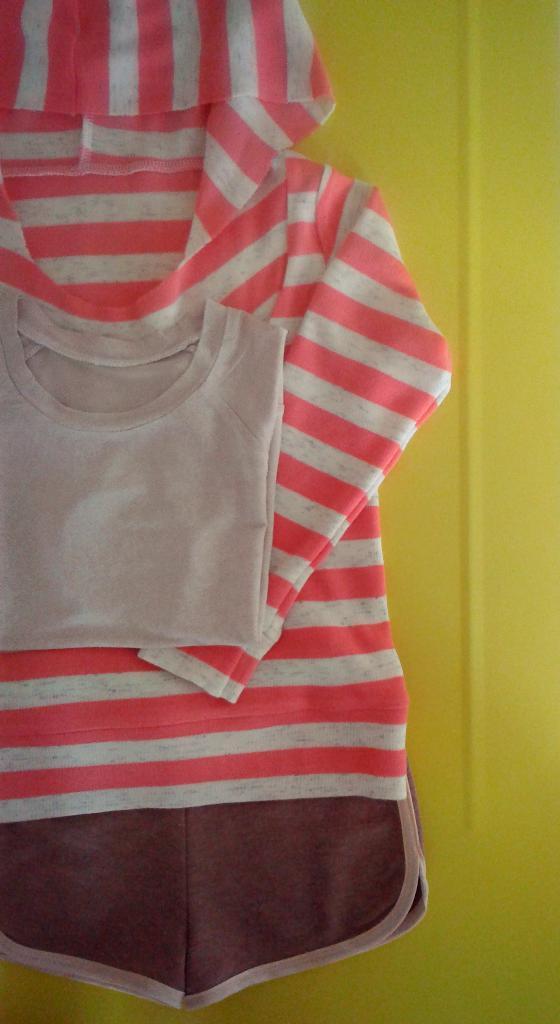In one or two sentences, can you explain what this image depicts? In this picture there is a cream color t-shirt and there is a pink and cream striped dress. At the back there is a yellow color background. 